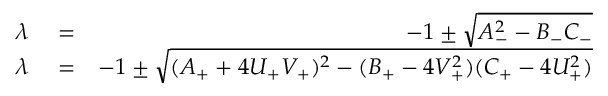Convert formula to latex. <formula><loc_0><loc_0><loc_500><loc_500>\begin{array} { r l r } { \lambda } & = } & { - 1 \pm \sqrt { A _ { - } ^ { 2 } - B _ { - } C _ { - } } } \\ { \lambda } & = } & { - 1 \pm \sqrt { ( A _ { + } + 4 U _ { + } V _ { + } ) ^ { 2 } - ( B _ { + } - 4 V _ { + } ^ { 2 } ) ( C _ { + } - 4 U _ { + } ^ { 2 } ) } } \end{array}</formula> 